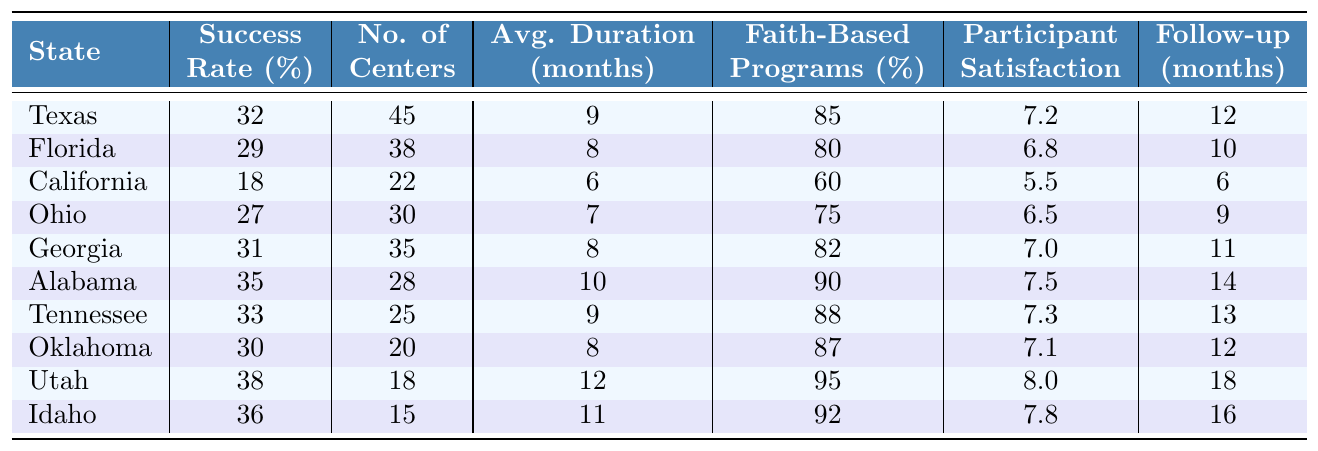What is the Conversion Therapy Success Rate in Texas? According to the table, Texas has a Conversion Therapy Success Rate of 32%.
Answer: 32% Which state has the highest rate of Conversion Therapy success? Upon examining the table, Utah has the highest Conversion Therapy Success Rate at 38%.
Answer: Utah How many Conversion Therapy Centers are there in Florida? The table indicates that Florida has 38 Conversion Therapy Centers.
Answer: 38 What is the average duration of therapy in California? The table shows that the average duration of therapy in California is 6 months.
Answer: 6 months Are there more Conversion Therapy Centers in Georgia than in Ohio? The table shows Georgia has 35 centers and Ohio has 30 centers, so yes, Georgia has more centers.
Answer: Yes What is the average Satisfaction Rating for participants in Alabama and Florida combined? Alabama has a Satisfaction Rating of 7.5 and Florida has a rating of 6.8. Adding them gives 14.3, and dividing by 2 for the average results in 7.15.
Answer: 7.15 Is there a state among the listed ones with a Conversion Therapy Success Rate above 35%? Checking the table reveals that Alabama (35%) and Utah (38%) have Success Rates above 35%.
Answer: Yes Which state reported the lowest participant satisfaction? The table reveals that California reported the lowest participant satisfaction score of 5.5.
Answer: California What is the difference in the number of Conversion Therapy Centers between Idaho and Oklahoma? Idaho has 15 centers and Oklahoma has 20 centers. The difference is 20 - 15 = 5 centers.
Answer: 5 Centers Calculate the average Follow-up Support Duration across all states in the table. Summing the Follow-up Support Durations (12, 10, 6, 9, 11, 14, 13, 12, 18, 16) gives a total of 131. Dividing by the number of states (10) results in an average of 13.1 months.
Answer: 13.1 months Which state has the highest percentage of faith-based programs? The table shows that Utah has the highest percentage of faith-based programs at 95%.
Answer: Utah 